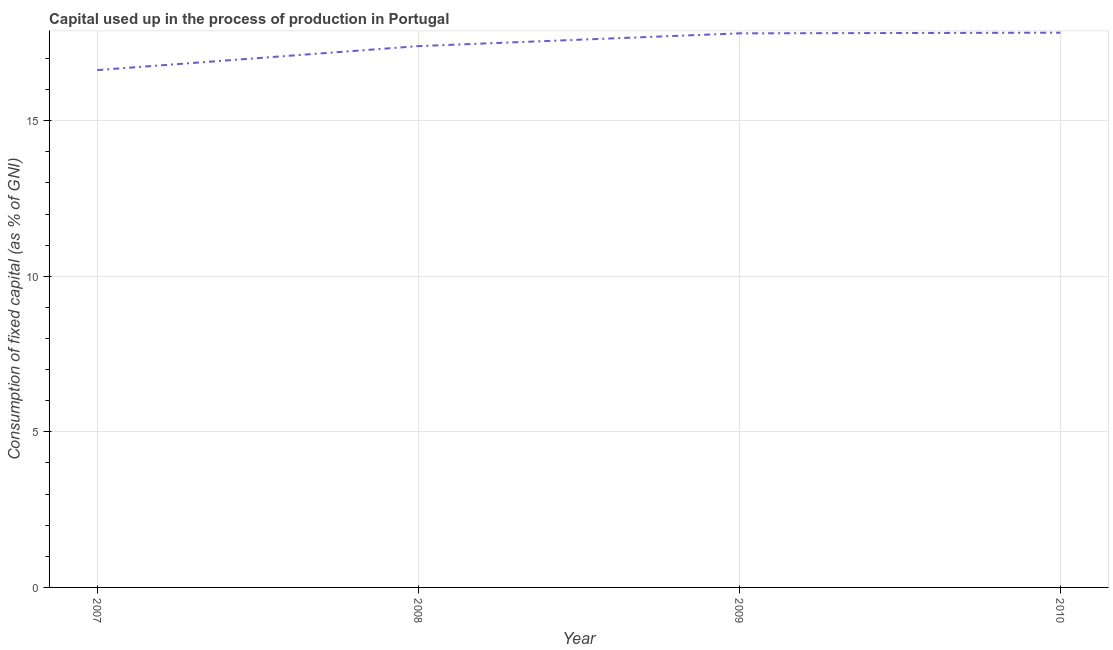What is the consumption of fixed capital in 2007?
Your answer should be compact. 16.63. Across all years, what is the maximum consumption of fixed capital?
Give a very brief answer. 17.83. Across all years, what is the minimum consumption of fixed capital?
Offer a very short reply. 16.63. What is the sum of the consumption of fixed capital?
Your answer should be very brief. 69.66. What is the difference between the consumption of fixed capital in 2008 and 2009?
Make the answer very short. -0.41. What is the average consumption of fixed capital per year?
Your response must be concise. 17.41. What is the median consumption of fixed capital?
Make the answer very short. 17.6. In how many years, is the consumption of fixed capital greater than 9 %?
Make the answer very short. 4. Do a majority of the years between 2010 and 2009 (inclusive) have consumption of fixed capital greater than 8 %?
Make the answer very short. No. What is the ratio of the consumption of fixed capital in 2007 to that in 2009?
Your answer should be very brief. 0.93. What is the difference between the highest and the second highest consumption of fixed capital?
Your response must be concise. 0.02. What is the difference between the highest and the lowest consumption of fixed capital?
Provide a short and direct response. 1.2. In how many years, is the consumption of fixed capital greater than the average consumption of fixed capital taken over all years?
Offer a terse response. 2. How many lines are there?
Give a very brief answer. 1. What is the difference between two consecutive major ticks on the Y-axis?
Provide a short and direct response. 5. Are the values on the major ticks of Y-axis written in scientific E-notation?
Keep it short and to the point. No. What is the title of the graph?
Make the answer very short. Capital used up in the process of production in Portugal. What is the label or title of the X-axis?
Offer a very short reply. Year. What is the label or title of the Y-axis?
Provide a succinct answer. Consumption of fixed capital (as % of GNI). What is the Consumption of fixed capital (as % of GNI) in 2007?
Keep it short and to the point. 16.63. What is the Consumption of fixed capital (as % of GNI) in 2008?
Your response must be concise. 17.4. What is the Consumption of fixed capital (as % of GNI) of 2009?
Offer a terse response. 17.81. What is the Consumption of fixed capital (as % of GNI) of 2010?
Offer a terse response. 17.83. What is the difference between the Consumption of fixed capital (as % of GNI) in 2007 and 2008?
Provide a succinct answer. -0.77. What is the difference between the Consumption of fixed capital (as % of GNI) in 2007 and 2009?
Ensure brevity in your answer.  -1.18. What is the difference between the Consumption of fixed capital (as % of GNI) in 2007 and 2010?
Provide a succinct answer. -1.2. What is the difference between the Consumption of fixed capital (as % of GNI) in 2008 and 2009?
Make the answer very short. -0.41. What is the difference between the Consumption of fixed capital (as % of GNI) in 2008 and 2010?
Your response must be concise. -0.43. What is the difference between the Consumption of fixed capital (as % of GNI) in 2009 and 2010?
Your answer should be compact. -0.02. What is the ratio of the Consumption of fixed capital (as % of GNI) in 2007 to that in 2008?
Provide a succinct answer. 0.96. What is the ratio of the Consumption of fixed capital (as % of GNI) in 2007 to that in 2009?
Provide a succinct answer. 0.93. What is the ratio of the Consumption of fixed capital (as % of GNI) in 2007 to that in 2010?
Your answer should be compact. 0.93. What is the ratio of the Consumption of fixed capital (as % of GNI) in 2008 to that in 2009?
Keep it short and to the point. 0.98. What is the ratio of the Consumption of fixed capital (as % of GNI) in 2009 to that in 2010?
Provide a short and direct response. 1. 